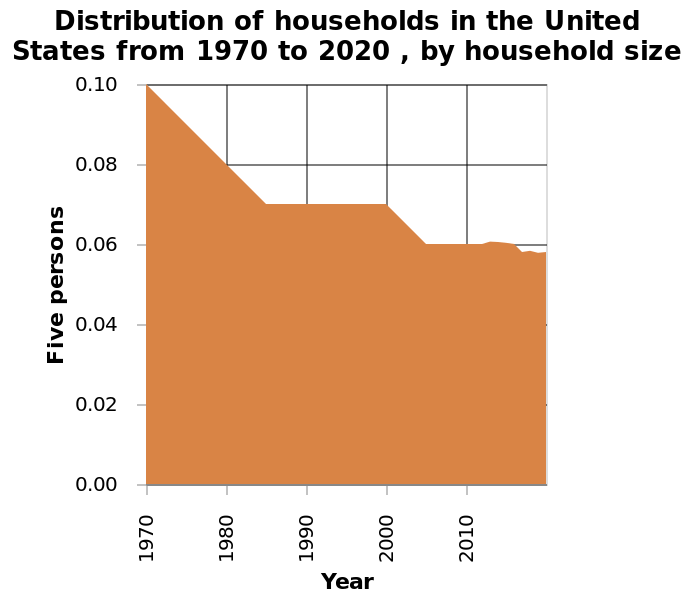<image>
What is the time period covered by the area plot? The time period covered by the area plot is from 1970 to 2020. Did the number of five person households change between 1985 and 2000?  No, the number of five person households remained constant between 1985 and 2000. 